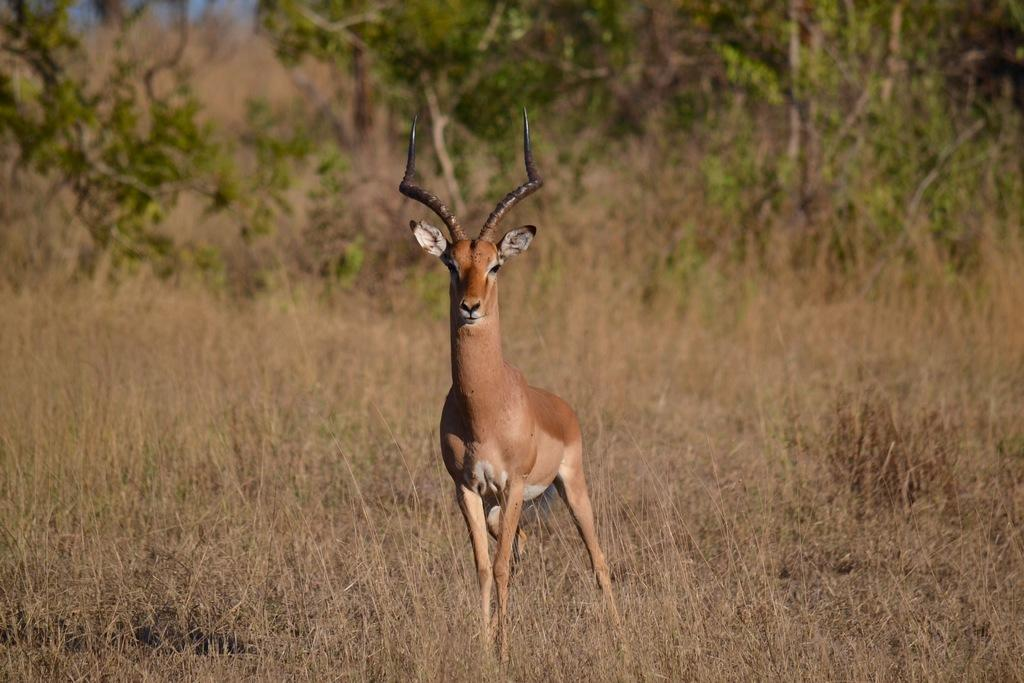What animal is present in the image? There is a deer in the image. What is the deer standing on in the image? The deer is standing on the grassland. What can be seen in the background of the image? There are trees in the background of the image. Where is the water source for the deer in the image? There is no water source visible in the image; it only shows a deer standing on the grassland with trees in the background. Can you see a basketball in the image? No, there is no basketball present in the image. 